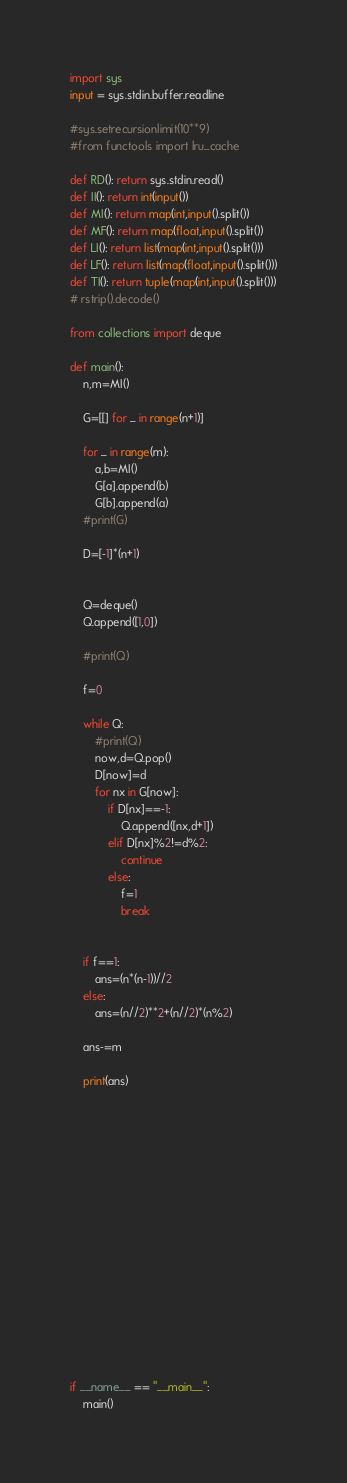Convert code to text. <code><loc_0><loc_0><loc_500><loc_500><_Python_>import sys
input = sys.stdin.buffer.readline

#sys.setrecursionlimit(10**9)
#from functools import lru_cache

def RD(): return sys.stdin.read()
def II(): return int(input())
def MI(): return map(int,input().split())
def MF(): return map(float,input().split())
def LI(): return list(map(int,input().split()))
def LF(): return list(map(float,input().split()))
def TI(): return tuple(map(int,input().split()))
# rstrip().decode()

from collections import deque

def main():
	n,m=MI()

	G=[[] for _ in range(n+1)]

	for _ in range(m):
		a,b=MI()
		G[a].append(b)
		G[b].append(a)
	#print(G)

	D=[-1]*(n+1)


	Q=deque()
	Q.append([1,0])

	#print(Q)

	f=0

	while Q:
		#print(Q)
		now,d=Q.pop()
		D[now]=d
		for nx in G[now]:
			if D[nx]==-1:
				Q.append([nx,d+1])
			elif D[nx]%2!=d%2:
				continue
			else:
				f=1
				break


	if f==1:
		ans=(n*(n-1))//2
	else:
		ans=(n//2)**2+(n//2)*(n%2)

	ans-=m

	print(ans)

















if __name__ == "__main__":
	main()
</code> 